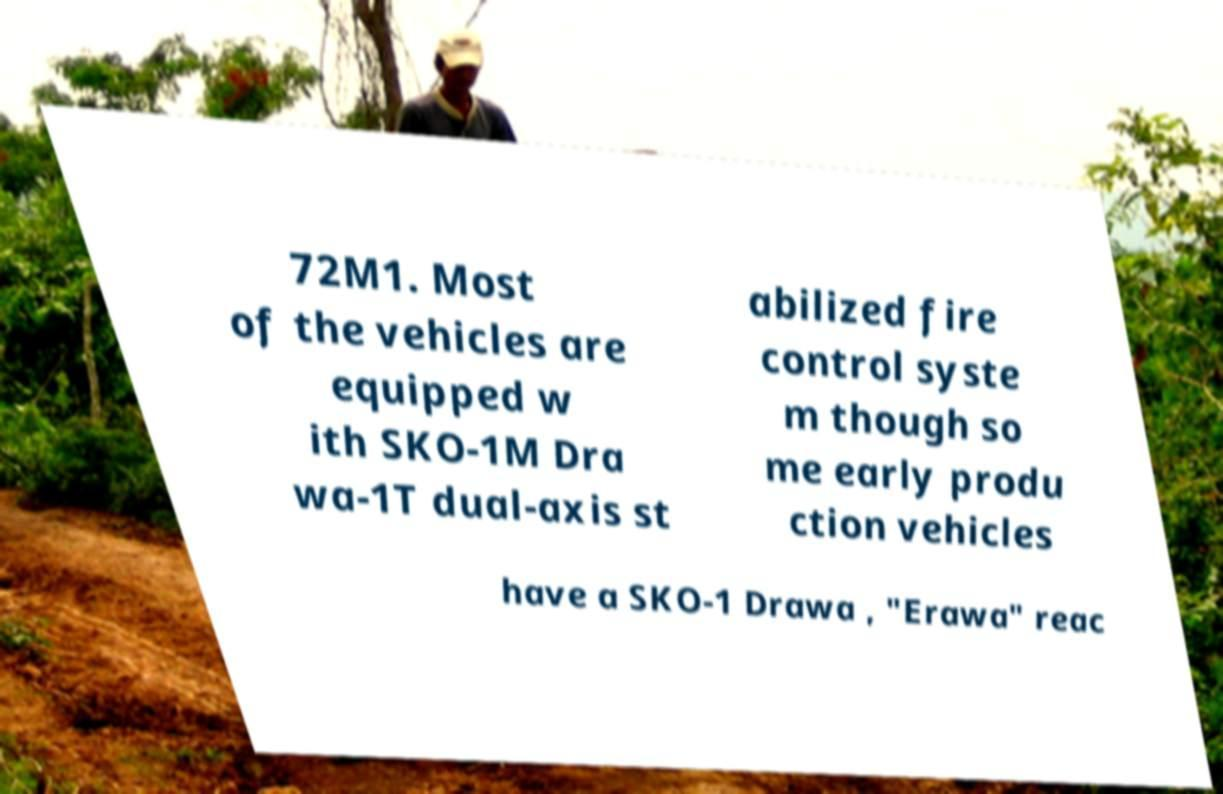Could you assist in decoding the text presented in this image and type it out clearly? 72M1. Most of the vehicles are equipped w ith SKO-1M Dra wa-1T dual-axis st abilized fire control syste m though so me early produ ction vehicles have a SKO-1 Drawa , "Erawa" reac 